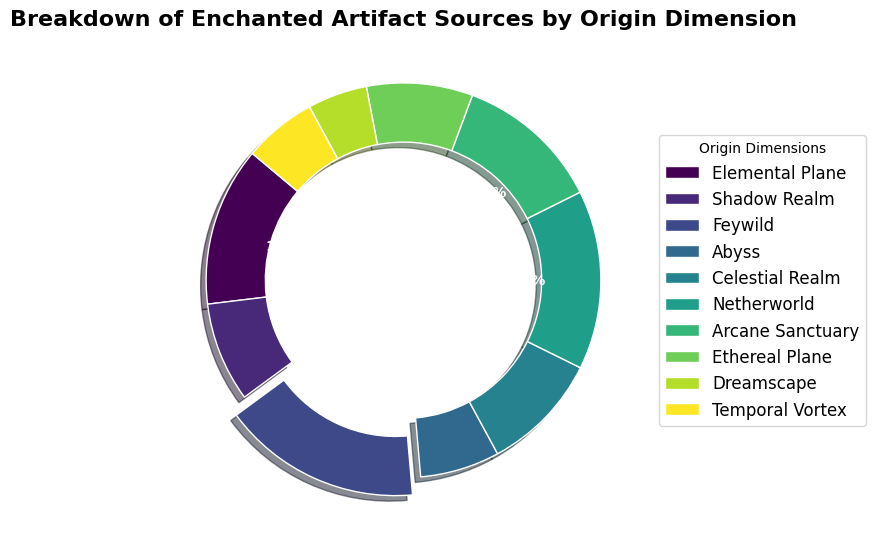Which origin dimension is the largest source of enchanted artifacts? Look at the pie chart and identify the segment with the highest percentage. The segment for Feywild is the largest.
Answer: Feywild Which origin dimension has the smallest contribution? Find the segment with the lowest percentage. The Dreamscape segment is the smallest.
Answer: Dreamscape How many more artifacts come from the Netherworld compared to the Abyss? Subtract the count of artifacts from Abyss (60) from the count of artifacts from Netherworld (135): 135 - 60 = 75.
Answer: 75 What is the percentage contribution of the Celestial Realm to the total artifacts? Find the segment labeled with the Celestial Realm and read off the percentage. The Celestial Realm contributes approximately 13.2%.
Answer: 13.2% What is the total number of artifacts from the Elemental Plane and the Arcane Sanctuary combined? Add the counts for Elemental Plane (120) and Arcane Sanctuary (110): 120 + 110 = 230.
Answer: 230 Comparing Ethereal Plane and Temporal Vortex, which has a higher artifact count and by how much? Subtract the count of artifacts from Temporal Vortex (55) from the count of artifacts from Ethereal Plane (80): 80 - 55 = 25. Ethereal Plane has more.
Answer: Ethereal Plane by 25 What is the sum of artifacts from dimensions contributing less than 70 artifacts each? Sum the counts for Shadow Realm (75), Abyss (60), Dreamscape (45), and Temporal Vortex (55), excluding the Shadow Realm as it contributes more than 70 artifacts: 60 + 45 + 55 = 160.
Answer: 160 How many dimensions have an artifact count greater than 100? Count the segments representing artifact counts greater than 100: Elemental Plane (120), Feywild (150), Netherworld (135), and Arcane Sanctuary (110) give a total of 4.
Answer: 4 Is the contribution of Elemental Plane and Celestial Realm combined greater than the contribution of the Feywild? Add the counts for Elemental Plane (120) and Celestial Realm (90): 120 + 90 = 210. Compare with Feywild (150). Since 210 > 150, it is greater.
Answer: Yes Which color represents artifacts from the Shadow Realm in the chart? Look for the segment labeled Shadow Realm and identify its color. As per the color scheme, it is a shade of green (specific shade from 'viridis').
Answer: Green (specific shade from 'viridis') 